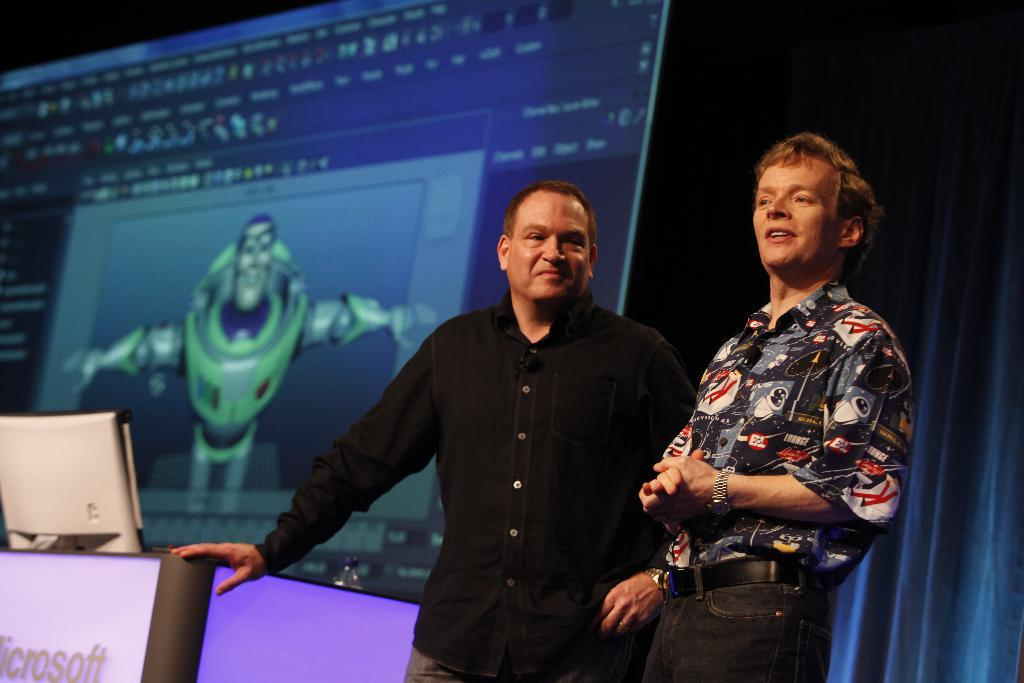How many people are in the image? There are two people standing in the image. What is one person doing with their hand? One person has their hand on the table. What electronic device is present in the image? There is a monitor in the image. What type of container is visible in the image? There is a bottle in the image. What can be seen in the background of the image? There is a screen and a curtain in the background of the image. What type of credit card is being used by the person in the image? There is no credit card visible in the image. What type of bushes can be seen in the background of the image? There are no bushes present in the image; only a screen and a curtain can be seen in the background. 